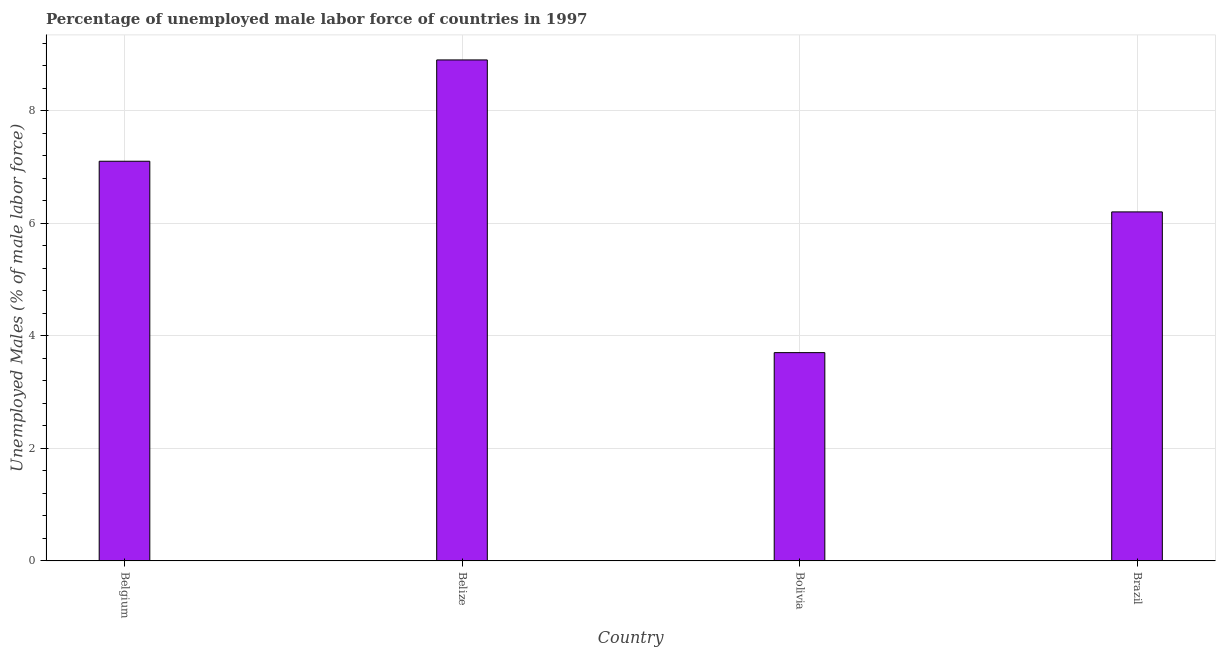Does the graph contain any zero values?
Ensure brevity in your answer.  No. Does the graph contain grids?
Offer a very short reply. Yes. What is the title of the graph?
Your response must be concise. Percentage of unemployed male labor force of countries in 1997. What is the label or title of the X-axis?
Ensure brevity in your answer.  Country. What is the label or title of the Y-axis?
Your response must be concise. Unemployed Males (% of male labor force). What is the total unemployed male labour force in Brazil?
Offer a terse response. 6.2. Across all countries, what is the maximum total unemployed male labour force?
Offer a very short reply. 8.9. Across all countries, what is the minimum total unemployed male labour force?
Your answer should be compact. 3.7. In which country was the total unemployed male labour force maximum?
Make the answer very short. Belize. What is the sum of the total unemployed male labour force?
Offer a terse response. 25.9. What is the difference between the total unemployed male labour force in Bolivia and Brazil?
Your response must be concise. -2.5. What is the average total unemployed male labour force per country?
Offer a terse response. 6.47. What is the median total unemployed male labour force?
Your response must be concise. 6.65. In how many countries, is the total unemployed male labour force greater than 4.4 %?
Ensure brevity in your answer.  3. What is the ratio of the total unemployed male labour force in Belize to that in Bolivia?
Ensure brevity in your answer.  2.4. Is the total unemployed male labour force in Belgium less than that in Brazil?
Your answer should be very brief. No. Is the difference between the total unemployed male labour force in Belgium and Brazil greater than the difference between any two countries?
Provide a short and direct response. No. What is the difference between the highest and the second highest total unemployed male labour force?
Your response must be concise. 1.8. In how many countries, is the total unemployed male labour force greater than the average total unemployed male labour force taken over all countries?
Make the answer very short. 2. Are all the bars in the graph horizontal?
Give a very brief answer. No. How many countries are there in the graph?
Keep it short and to the point. 4. What is the difference between two consecutive major ticks on the Y-axis?
Your answer should be compact. 2. Are the values on the major ticks of Y-axis written in scientific E-notation?
Give a very brief answer. No. What is the Unemployed Males (% of male labor force) of Belgium?
Ensure brevity in your answer.  7.1. What is the Unemployed Males (% of male labor force) in Belize?
Give a very brief answer. 8.9. What is the Unemployed Males (% of male labor force) in Bolivia?
Make the answer very short. 3.7. What is the Unemployed Males (% of male labor force) of Brazil?
Keep it short and to the point. 6.2. What is the difference between the Unemployed Males (% of male labor force) in Belgium and Belize?
Your answer should be very brief. -1.8. What is the difference between the Unemployed Males (% of male labor force) in Belize and Bolivia?
Keep it short and to the point. 5.2. What is the difference between the Unemployed Males (% of male labor force) in Belize and Brazil?
Provide a short and direct response. 2.7. What is the ratio of the Unemployed Males (% of male labor force) in Belgium to that in Belize?
Offer a very short reply. 0.8. What is the ratio of the Unemployed Males (% of male labor force) in Belgium to that in Bolivia?
Give a very brief answer. 1.92. What is the ratio of the Unemployed Males (% of male labor force) in Belgium to that in Brazil?
Ensure brevity in your answer.  1.15. What is the ratio of the Unemployed Males (% of male labor force) in Belize to that in Bolivia?
Make the answer very short. 2.4. What is the ratio of the Unemployed Males (% of male labor force) in Belize to that in Brazil?
Ensure brevity in your answer.  1.44. What is the ratio of the Unemployed Males (% of male labor force) in Bolivia to that in Brazil?
Your answer should be compact. 0.6. 